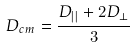<formula> <loc_0><loc_0><loc_500><loc_500>D _ { c m } = \frac { D _ { | | } + 2 D _ { \perp } } { 3 }</formula> 